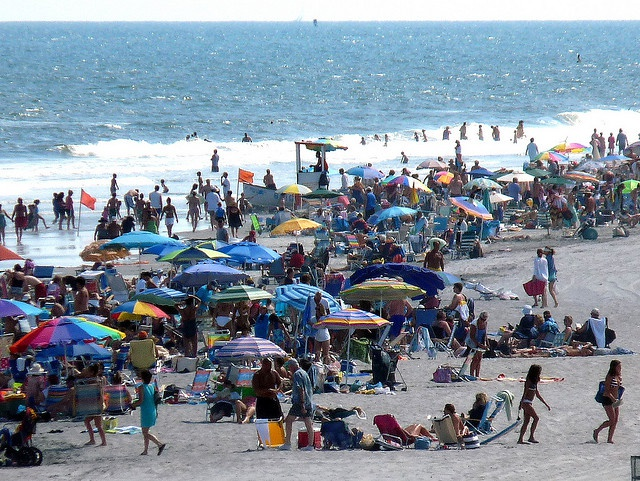Describe the objects in this image and their specific colors. I can see people in white, black, gray, and darkgray tones, umbrella in white, gray, and black tones, umbrella in white, blue, maroon, and purple tones, people in white, black, gray, darkgray, and navy tones, and umbrella in white, navy, and gray tones in this image. 